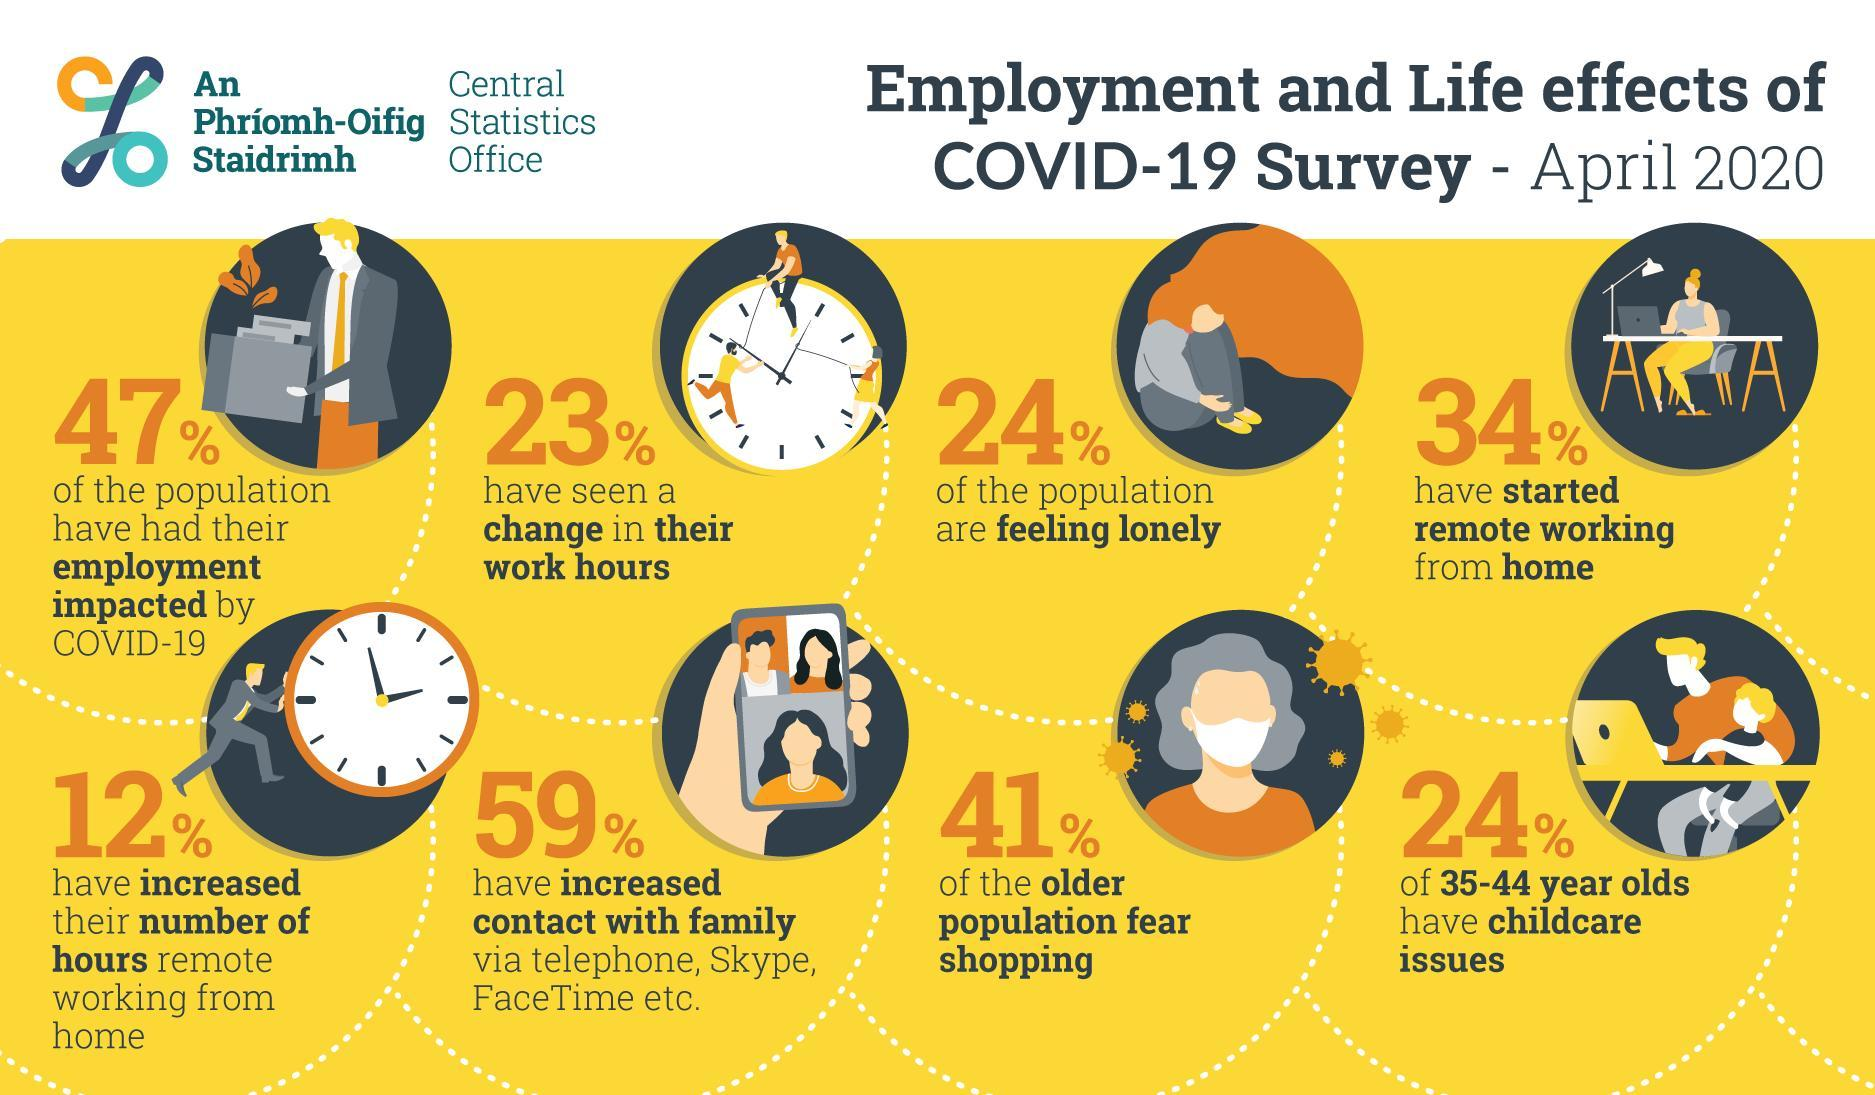What is the color of the mask, one of the avatars is wearing  in this infographic - blue,white, black or red?
Answer the question with a short phrase. white Among people in 35-44 age group what percentage have childcare issues? 24% For what percentage of the surveyed people, was there are change in the work hours? 23% Among those surveyed what percentage do not feel lonely? 76% Among the older population what percentage fear shopping? 41% According to this survey results, what percentage of people feel lonely? 24% 